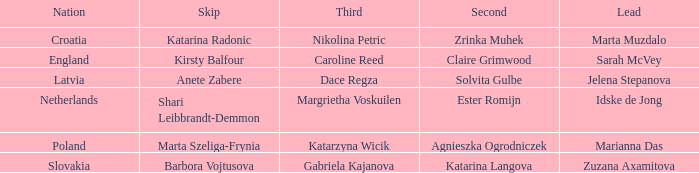What is the name of the second who has Caroline Reed as third? Claire Grimwood. 